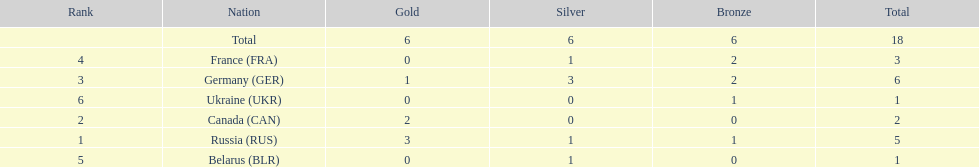What country only received gold medals in the 1994 winter olympics biathlon? Canada (CAN). 